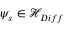Convert formula to latex. <formula><loc_0><loc_0><loc_500><loc_500>\psi _ { s } \in { \mathcal { H } } _ { D i f f }</formula> 